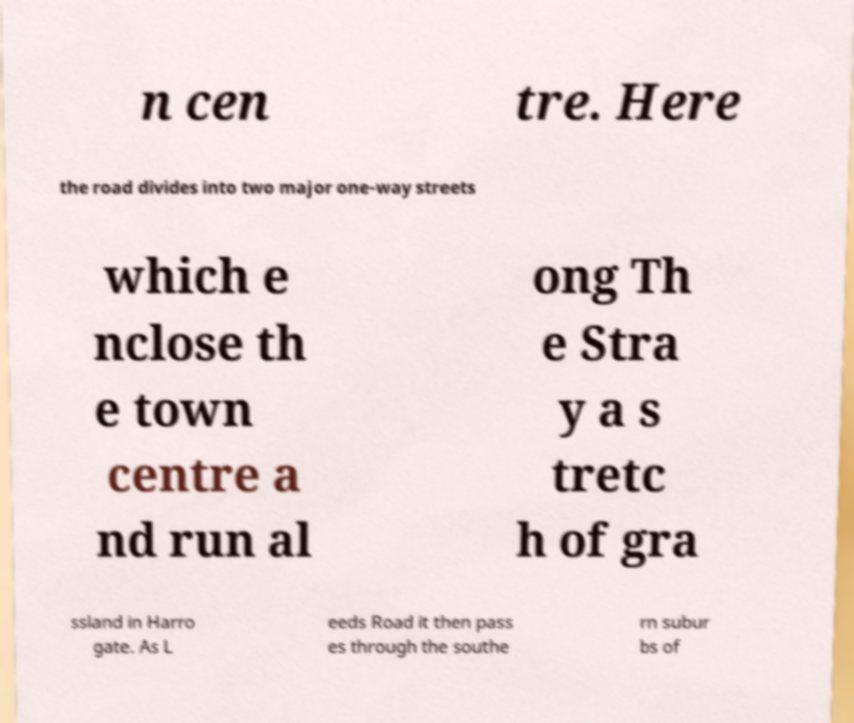I need the written content from this picture converted into text. Can you do that? n cen tre. Here the road divides into two major one-way streets which e nclose th e town centre a nd run al ong Th e Stra y a s tretc h of gra ssland in Harro gate. As L eeds Road it then pass es through the southe rn subur bs of 